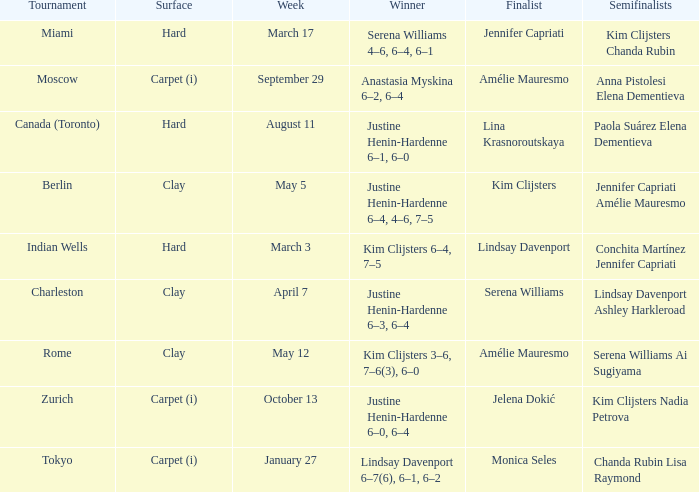Who was the finalist in Miami? Jennifer Capriati. 